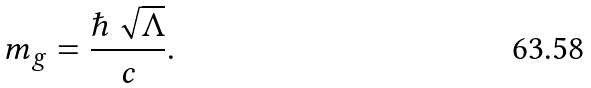Convert formula to latex. <formula><loc_0><loc_0><loc_500><loc_500>m _ { g } = \frac { \hbar { \, } \sqrt { \Lambda } } { c } .</formula> 